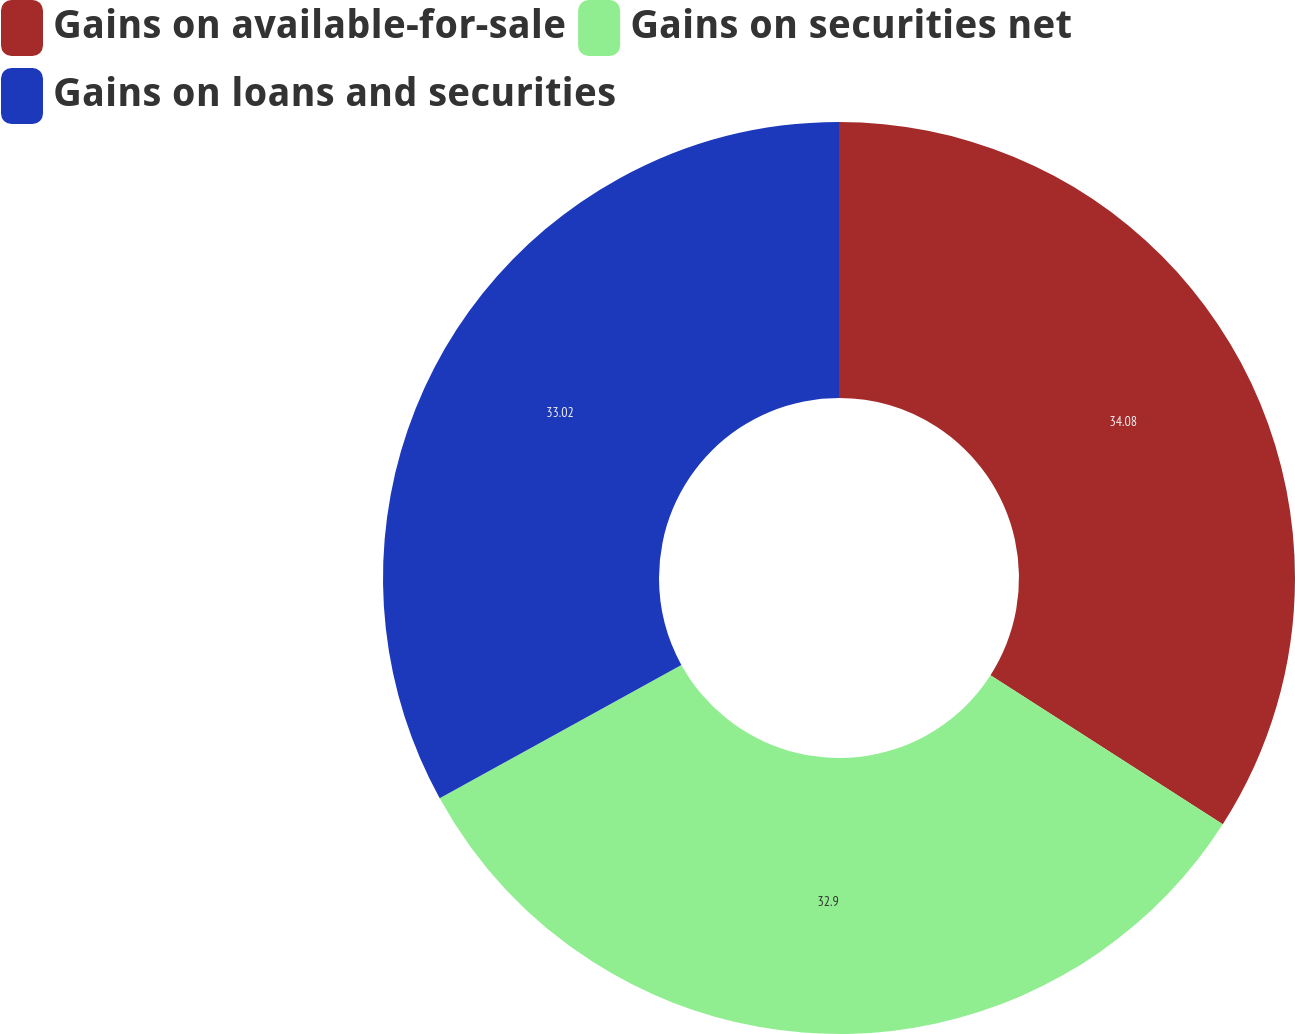Convert chart to OTSL. <chart><loc_0><loc_0><loc_500><loc_500><pie_chart><fcel>Gains on available-for-sale<fcel>Gains on securities net<fcel>Gains on loans and securities<nl><fcel>34.08%<fcel>32.9%<fcel>33.02%<nl></chart> 